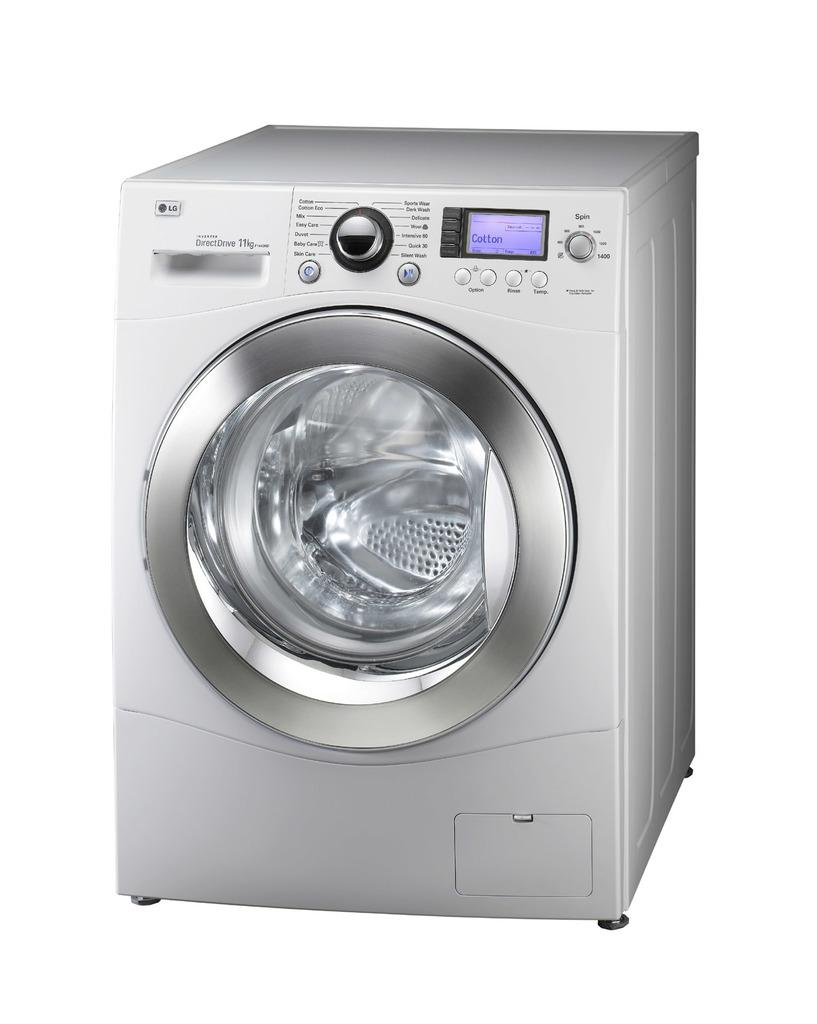What appliance is the main subject of the image? There is a washing machine in the image. Where is the washing machine located in the image? The washing machine is in the center of the image. What type of potato is being used to create the smile on the washing machine in the image? There is no potato or smile present on the washing machine in the image. 